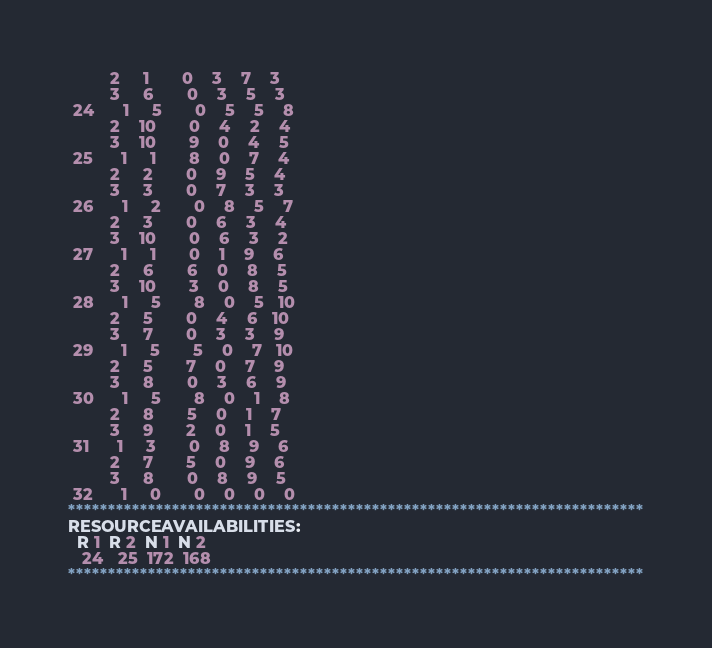Convert code to text. <code><loc_0><loc_0><loc_500><loc_500><_ObjectiveC_>         2     1       0    3    7    3
         3     6       0    3    5    3
 24      1     5       0    5    5    8
         2    10       0    4    2    4
         3    10       9    0    4    5
 25      1     1       8    0    7    4
         2     2       0    9    5    4
         3     3       0    7    3    3
 26      1     2       0    8    5    7
         2     3       0    6    3    4
         3    10       0    6    3    2
 27      1     1       0    1    9    6
         2     6       6    0    8    5
         3    10       3    0    8    5
 28      1     5       8    0    5   10
         2     5       0    4    6   10
         3     7       0    3    3    9
 29      1     5       5    0    7   10
         2     5       7    0    7    9
         3     8       0    3    6    9
 30      1     5       8    0    1    8
         2     8       5    0    1    7
         3     9       2    0    1    5
 31      1     3       0    8    9    6
         2     7       5    0    9    6
         3     8       0    8    9    5
 32      1     0       0    0    0    0
************************************************************************
RESOURCEAVAILABILITIES:
  R 1  R 2  N 1  N 2
   24   25  172  168
************************************************************************
</code> 